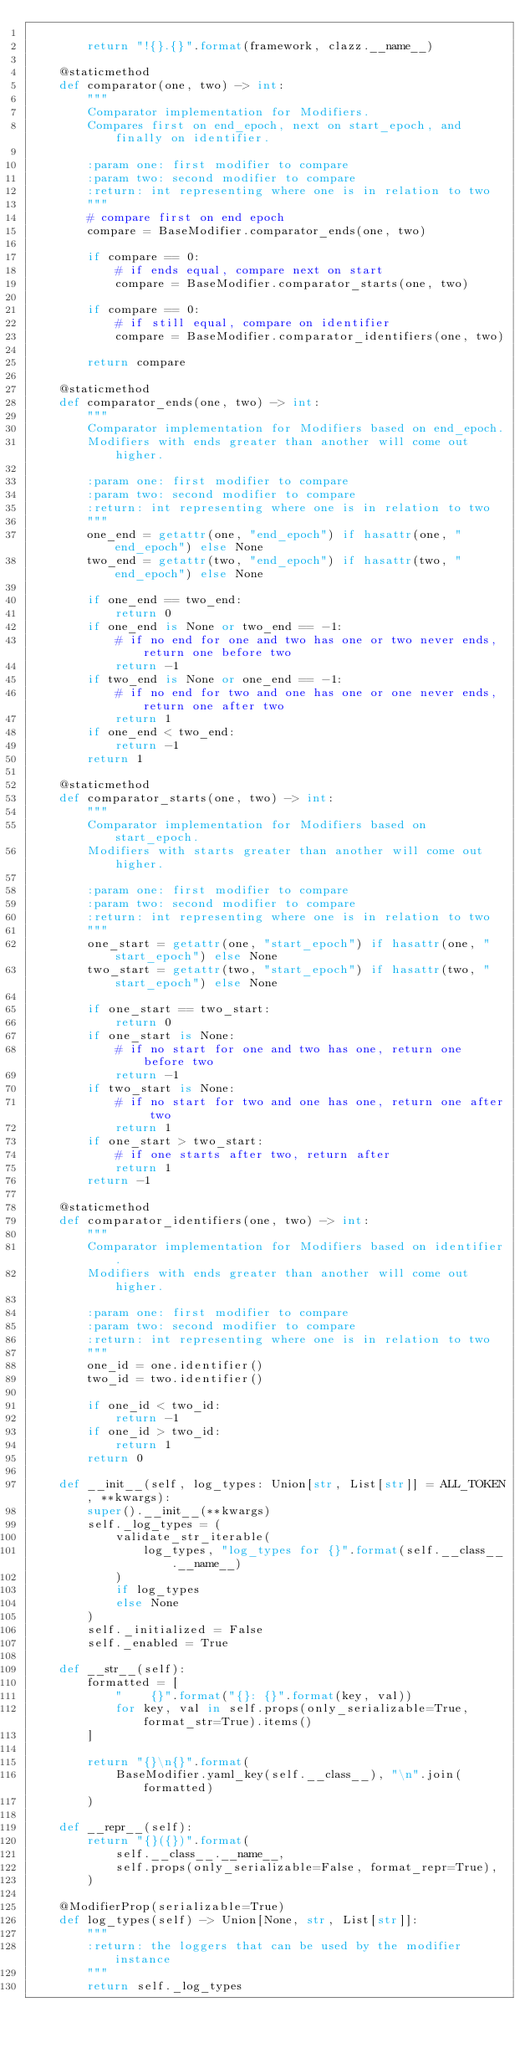Convert code to text. <code><loc_0><loc_0><loc_500><loc_500><_Python_>
        return "!{}.{}".format(framework, clazz.__name__)

    @staticmethod
    def comparator(one, two) -> int:
        """
        Comparator implementation for Modifiers.
        Compares first on end_epoch, next on start_epoch, and finally on identifier.

        :param one: first modifier to compare
        :param two: second modifier to compare
        :return: int representing where one is in relation to two
        """
        # compare first on end epoch
        compare = BaseModifier.comparator_ends(one, two)

        if compare == 0:
            # if ends equal, compare next on start
            compare = BaseModifier.comparator_starts(one, two)

        if compare == 0:
            # if still equal, compare on identifier
            compare = BaseModifier.comparator_identifiers(one, two)

        return compare

    @staticmethod
    def comparator_ends(one, two) -> int:
        """
        Comparator implementation for Modifiers based on end_epoch.
        Modifiers with ends greater than another will come out higher.

        :param one: first modifier to compare
        :param two: second modifier to compare
        :return: int representing where one is in relation to two
        """
        one_end = getattr(one, "end_epoch") if hasattr(one, "end_epoch") else None
        two_end = getattr(two, "end_epoch") if hasattr(two, "end_epoch") else None

        if one_end == two_end:
            return 0
        if one_end is None or two_end == -1:
            # if no end for one and two has one or two never ends, return one before two
            return -1
        if two_end is None or one_end == -1:
            # if no end for two and one has one or one never ends, return one after two
            return 1
        if one_end < two_end:
            return -1
        return 1

    @staticmethod
    def comparator_starts(one, two) -> int:
        """
        Comparator implementation for Modifiers based on start_epoch.
        Modifiers with starts greater than another will come out higher.

        :param one: first modifier to compare
        :param two: second modifier to compare
        :return: int representing where one is in relation to two
        """
        one_start = getattr(one, "start_epoch") if hasattr(one, "start_epoch") else None
        two_start = getattr(two, "start_epoch") if hasattr(two, "start_epoch") else None

        if one_start == two_start:
            return 0
        if one_start is None:
            # if no start for one and two has one, return one before two
            return -1
        if two_start is None:
            # if no start for two and one has one, return one after two
            return 1
        if one_start > two_start:
            # if one starts after two, return after
            return 1
        return -1

    @staticmethod
    def comparator_identifiers(one, two) -> int:
        """
        Comparator implementation for Modifiers based on identifier.
        Modifiers with ends greater than another will come out higher.

        :param one: first modifier to compare
        :param two: second modifier to compare
        :return: int representing where one is in relation to two
        """
        one_id = one.identifier()
        two_id = two.identifier()

        if one_id < two_id:
            return -1
        if one_id > two_id:
            return 1
        return 0

    def __init__(self, log_types: Union[str, List[str]] = ALL_TOKEN, **kwargs):
        super().__init__(**kwargs)
        self._log_types = (
            validate_str_iterable(
                log_types, "log_types for {}".format(self.__class__.__name__)
            )
            if log_types
            else None
        )
        self._initialized = False
        self._enabled = True

    def __str__(self):
        formatted = [
            "    {}".format("{}: {}".format(key, val))
            for key, val in self.props(only_serializable=True, format_str=True).items()
        ]

        return "{}\n{}".format(
            BaseModifier.yaml_key(self.__class__), "\n".join(formatted)
        )

    def __repr__(self):
        return "{}({})".format(
            self.__class__.__name__,
            self.props(only_serializable=False, format_repr=True),
        )

    @ModifierProp(serializable=True)
    def log_types(self) -> Union[None, str, List[str]]:
        """
        :return: the loggers that can be used by the modifier instance
        """
        return self._log_types
</code> 